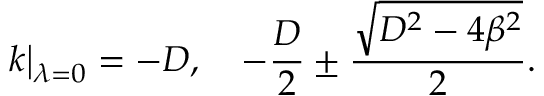<formula> <loc_0><loc_0><loc_500><loc_500>k \right | _ { \lambda = 0 } = - D , \quad - \frac { D } { 2 } \pm \frac { \sqrt { D ^ { 2 } - 4 \beta ^ { 2 } } } { 2 } .</formula> 